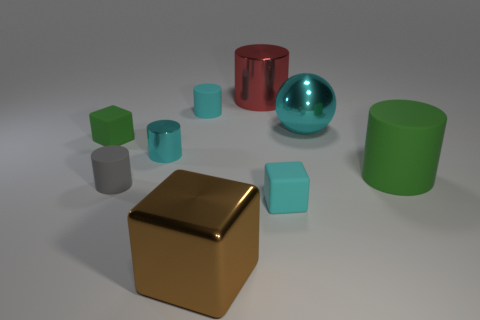Subtract all small gray matte cylinders. How many cylinders are left? 4 Subtract all blocks. How many objects are left? 6 Subtract 1 blocks. How many blocks are left? 2 Subtract all large cyan objects. Subtract all tiny cubes. How many objects are left? 6 Add 6 big matte cylinders. How many big matte cylinders are left? 7 Add 2 tiny cyan metallic things. How many tiny cyan metallic things exist? 3 Subtract all green cylinders. How many cylinders are left? 4 Subtract 1 cyan balls. How many objects are left? 8 Subtract all brown cylinders. Subtract all blue balls. How many cylinders are left? 5 Subtract all purple spheres. How many yellow cylinders are left? 0 